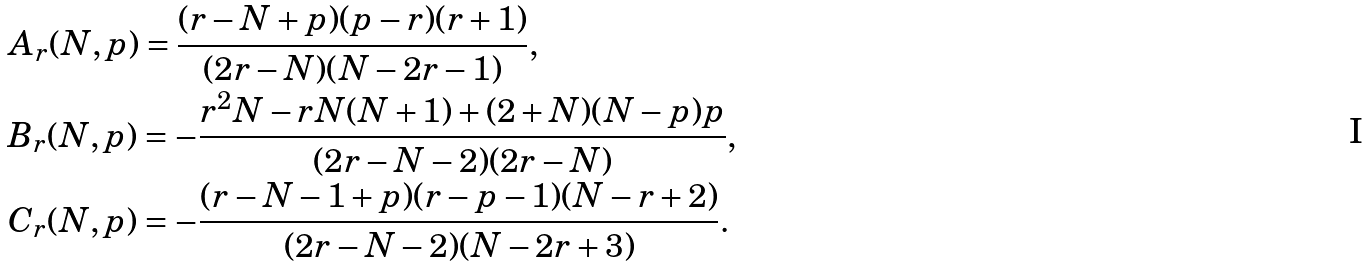<formula> <loc_0><loc_0><loc_500><loc_500>& A _ { r } ( N , p ) = \frac { ( r - N + p ) ( p - r ) ( r + 1 ) } { ( 2 r - N ) ( N - 2 r - 1 ) } , \\ & B _ { r } ( N , p ) = - \frac { r ^ { 2 } N - r N ( N + 1 ) + ( 2 + N ) ( N - p ) p } { ( 2 r - N - 2 ) ( 2 r - N ) } , \\ & C _ { r } ( N , p ) = - \frac { ( r - N - 1 + p ) ( r - p - 1 ) ( N - r + 2 ) } { ( 2 r - N - 2 ) ( N - 2 r + 3 ) } .</formula> 